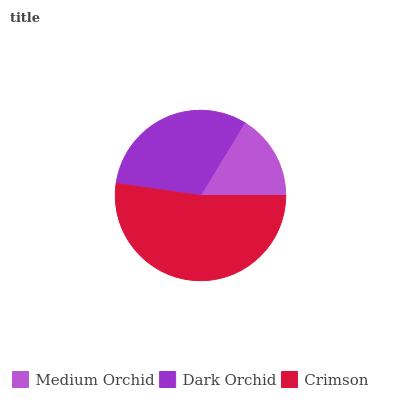Is Medium Orchid the minimum?
Answer yes or no. Yes. Is Crimson the maximum?
Answer yes or no. Yes. Is Dark Orchid the minimum?
Answer yes or no. No. Is Dark Orchid the maximum?
Answer yes or no. No. Is Dark Orchid greater than Medium Orchid?
Answer yes or no. Yes. Is Medium Orchid less than Dark Orchid?
Answer yes or no. Yes. Is Medium Orchid greater than Dark Orchid?
Answer yes or no. No. Is Dark Orchid less than Medium Orchid?
Answer yes or no. No. Is Dark Orchid the high median?
Answer yes or no. Yes. Is Dark Orchid the low median?
Answer yes or no. Yes. Is Medium Orchid the high median?
Answer yes or no. No. Is Crimson the low median?
Answer yes or no. No. 